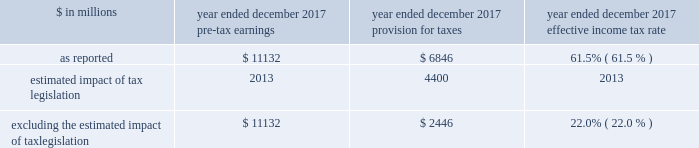The goldman sachs group , inc .
And subsidiaries management 2019s discussion and analysis as of december 2017 , total staff increased 6% ( 6 % ) compared with december 2016 , reflecting investments in technology and marcus , and support of our regulatory efforts .
2016 versus 2015 .
Operating expenses in the consolidated statements of earnings were $ 20.30 billion for 2016 , 19% ( 19 % ) lower than 2015 .
Compensation and benefits expenses in the consolidated statements of earnings were $ 11.65 billion for 2016 , 8% ( 8 % ) lower than 2015 , reflecting a decrease in net revenues and the impact of expense savings initiatives .
The ratio of compensation and benefits to net revenues for 2016 was 38.1% ( 38.1 % ) compared with 37.5% ( 37.5 % ) for 2015 .
Non-compensation expenses in the consolidated statements of earnings were $ 8.66 billion for 2016 , 30% ( 30 % ) lower than 2015 , primarily due to significantly lower net provisions for mortgage-related litigation and regulatory matters , which are included in other expenses .
In addition , market development expenses and professional fees were lower compared with 2015 , reflecting expense savings initiatives .
Net provisions for litigation and regulatory proceedings for 2016 were $ 396 million compared with $ 4.01 billion for 2015 ( 2015 primarily related to net provisions for mortgage-related matters ) .
2016 included a $ 114 million charitable contribution to goldman sachs gives .
Compensation was reduced to fund this charitable contribution to goldman sachs gives .
We ask our participating managing directors to make recommendations regarding potential charitable recipients for this contribution .
As of december 2016 , total staff decreased 7% ( 7 % ) compared with december 2015 , due to expense savings initiatives .
Provision for taxes the effective income tax rate for 2017 was 61.5% ( 61.5 % ) , up from 28.2% ( 28.2 % ) for 2016 .
The increase compared with 2016 reflected the estimated impact of tax legislation , which was enacted on december 22 , 2017 and , among other things , lowers u.s .
Corporate income tax rates as of january 1 , 2018 , implements a territorial tax system and imposes a repatriation tax on deemed repatriated earnings of foreign subsidiaries .
The estimated impact of tax legislation was an increase in income tax expense of $ 4.40 billion , of which $ 3.32 billion was due to the repatriation tax and $ 1.08 billion was due to the effects of the implementation of the territorial tax system and the remeasurement of u.s .
Deferred tax assets at lower enacted corporate tax rates .
The impact of tax legislation may differ from this estimate , possibly materially , due to , among other things , ( i ) refinement of our calculations based on updated information , ( ii ) changes in interpretations and assumptions , ( iii ) guidance that may be issued and ( iv ) actions we may take as a result of tax legislation .
Excluding the estimated impact of tax legislation , the effective income tax rate for 2017 was 22.0% ( 22.0 % ) , down from 28.2% ( 28.2 % ) for 2016 .
This decrease was primarily due to tax benefits on the settlement of employee share-based awards in accordance with asu no .
2016-09 .
The impact of these settlements in 2017 was a reduction to our provision for taxes of $ 719 million and a reduction in our effective income tax rate of 6.4 percentage points .
See note 3 to the consolidated financial statements for further information about this asu .
The effective income tax rate , excluding the estimated impact of tax legislation , is a non-gaap measure and may not be comparable to similar non-gaap measures used by other companies .
We believe that presenting our effective income tax rate , excluding the estimated impact of tax legislation is meaningful , as excluding this item increases the comparability of period-to-period results .
The table below presents the calculation of the effective income tax rate , excluding the estimated impact of tax legislation. .
Excluding the estimated impact of tax legislation $ 11132 $ 2446 22.0% ( 22.0 % ) the effective income tax rate for 2016 was 28.2% ( 28.2 % ) , down from 30.7% ( 30.7 % ) for 2015 .
The decline compared with 2015 was primarily due to the impact of non-deductible provisions for mortgage-related litigation and regulatory matters in 2015 , partially offset by the impact of changes in tax law on deferred tax assets , the mix of earnings and an increase related to higher enacted tax rates impacting certain of our u.k .
Subsidiaries in 2016 .
Effective january 1 , 2018 , tax legislation reduced the u.s .
Corporate tax rate to 21 percent , eliminated tax deductions for certain expenses and enacted two new taxes , base erosion and anti-abuse tax ( beat ) and global intangible low taxed income ( gilti ) .
Beat is an alternative minimum tax that applies to banks that pay more than 2 percent of total deductible expenses to certain foreign subsidiaries .
Gilti is a 10.5 percent tax , before allowable credits for foreign taxes paid , on the annual earnings and profits of certain foreign subsidiaries .
Based on our current understanding of these rules , the impact of beat and gilti is not expected to be material to our effective income tax rate .
Goldman sachs 2017 form 10-k 55 .
What was the change in percentage points in the effective income tax rate for 2017 from 2016? 
Computations: (28.2 - 22.0)
Answer: 6.2. 